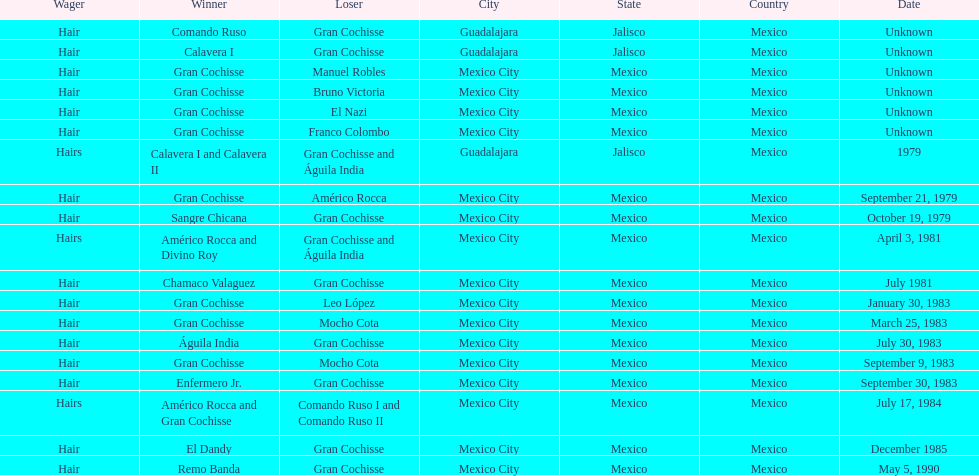How many times has the wager been hair? 16. 